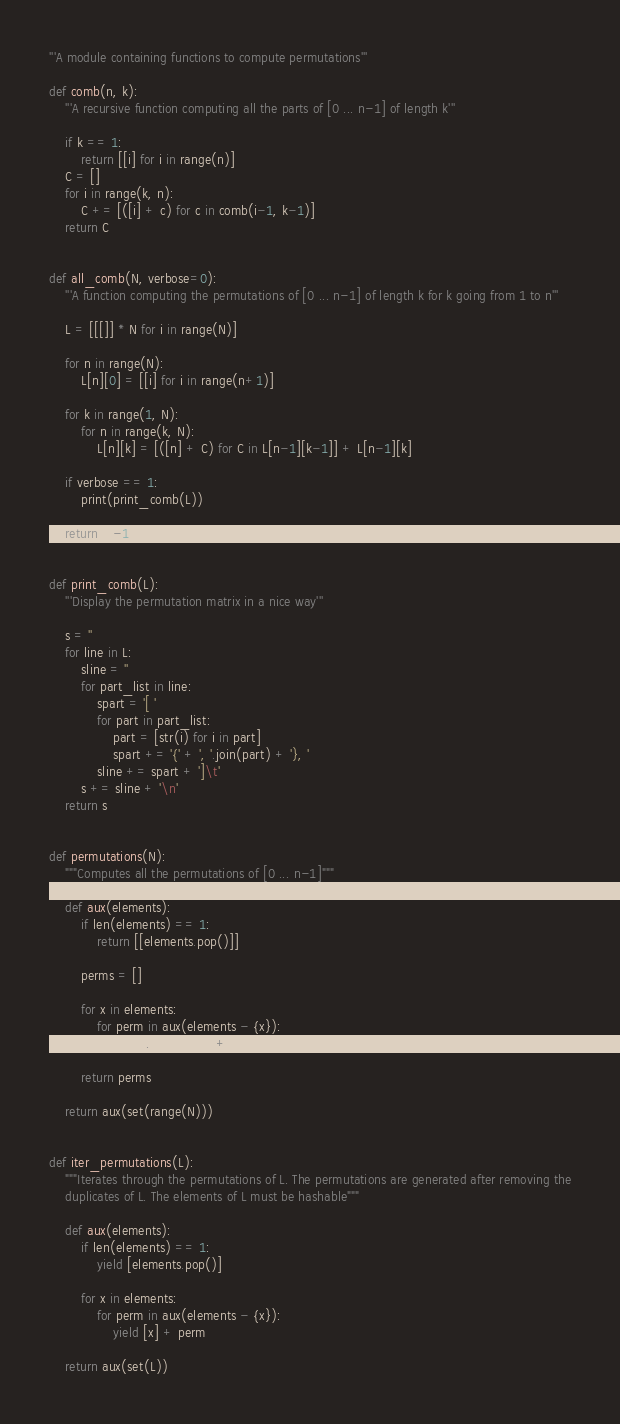<code> <loc_0><loc_0><loc_500><loc_500><_Python_>'''A module containing functions to compute permutations'''

def comb(n, k):
    '''A recursive function computing all the parts of [0 ... n-1] of length k'''

    if k == 1:
        return [[i] for i in range(n)]
    C = []
    for i in range(k, n):
        C += [([i] + c) for c in comb(i-1, k-1)]
    return C


def all_comb(N, verbose=0):
    '''A function computing the permutations of [0 ... n-1] of length k for k going from 1 to n'''

    L = [[[]] * N for i in range(N)]

    for n in range(N):
        L[n][0] = [[i] for i in range(n+1)]

    for k in range(1, N):
        for n in range(k, N):
            L[n][k] = [([n] + C) for C in L[n-1][k-1]] + L[n-1][k]

    if verbose == 1:
        print(print_comb(L))

    return L[-1]


def print_comb(L):
    '''Display the permutation matrix in a nice way'''

    s = ''
    for line in L:
        sline = ''
        for part_list in line:
            spart = '[ '
            for part in part_list:
                part = [str(i) for i in part]
                spart += '{' + ', '.join(part) + '}, '
            sline += spart + ']\t'
        s += sline + '\n'
    return s


def permutations(N):
    """Computes all the permutations of [0 ... n-1]"""

    def aux(elements):
        if len(elements) == 1:
            return [[elements.pop()]]

        perms = []

        for x in elements:
            for perm in aux(elements - {x}):
                perms.append([x] + perm)

        return perms

    return aux(set(range(N)))


def iter_permutations(L):
    """Iterates through the permutations of L. The permutations are generated after removing the
    duplicates of L. The elements of L must be hashable"""

    def aux(elements):
        if len(elements) == 1:
            yield [elements.pop()]

        for x in elements:
            for perm in aux(elements - {x}):
                yield [x] + perm

    return aux(set(L))
</code> 